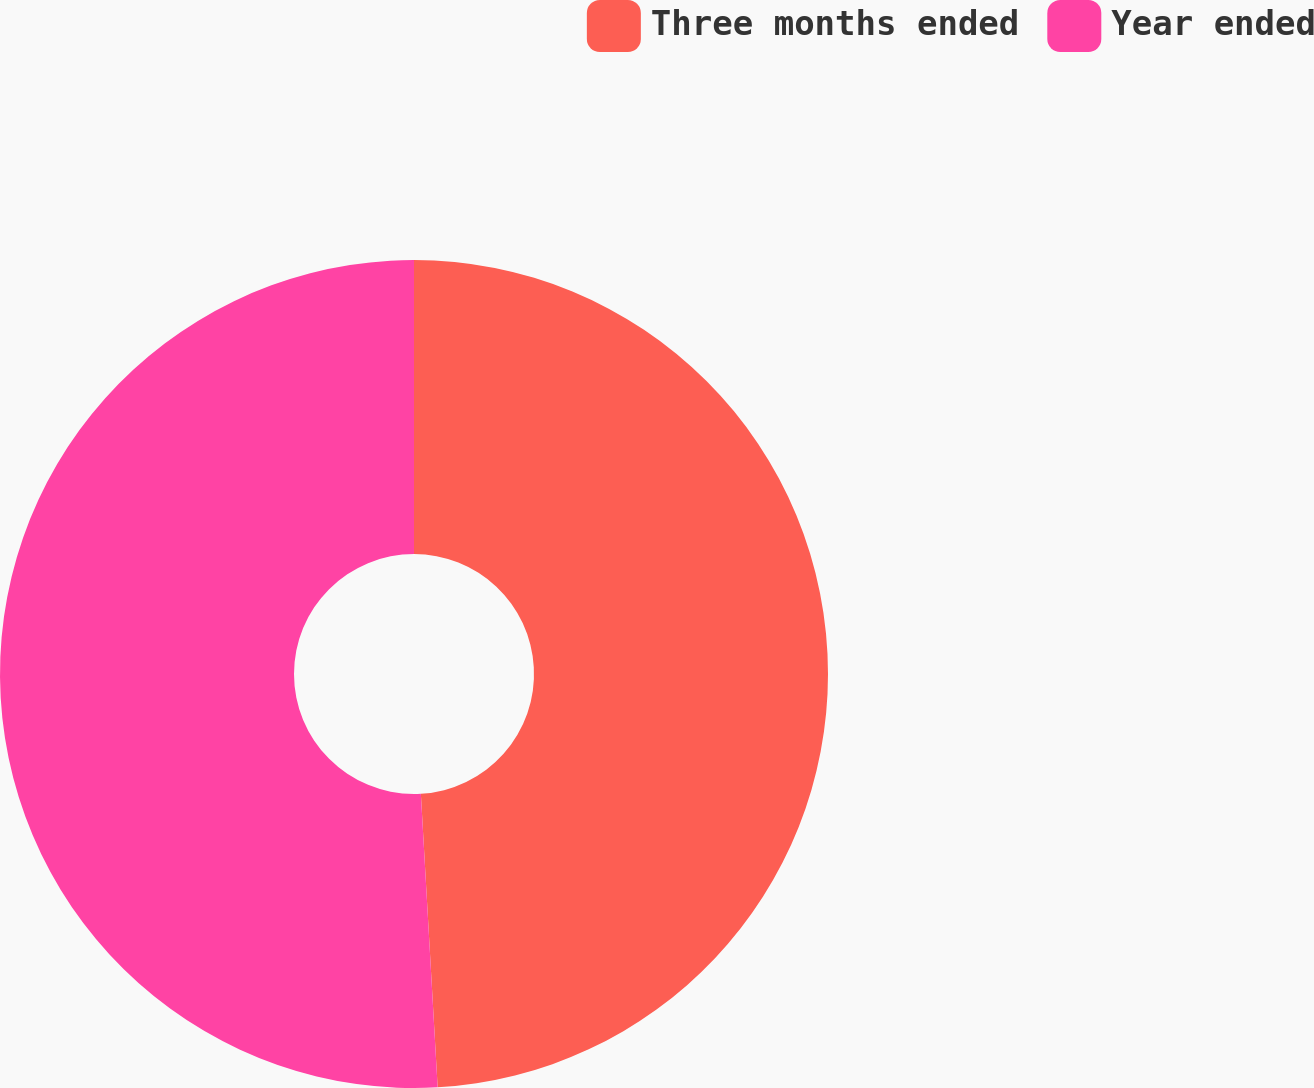Convert chart to OTSL. <chart><loc_0><loc_0><loc_500><loc_500><pie_chart><fcel>Three months ended<fcel>Year ended<nl><fcel>49.09%<fcel>50.91%<nl></chart> 